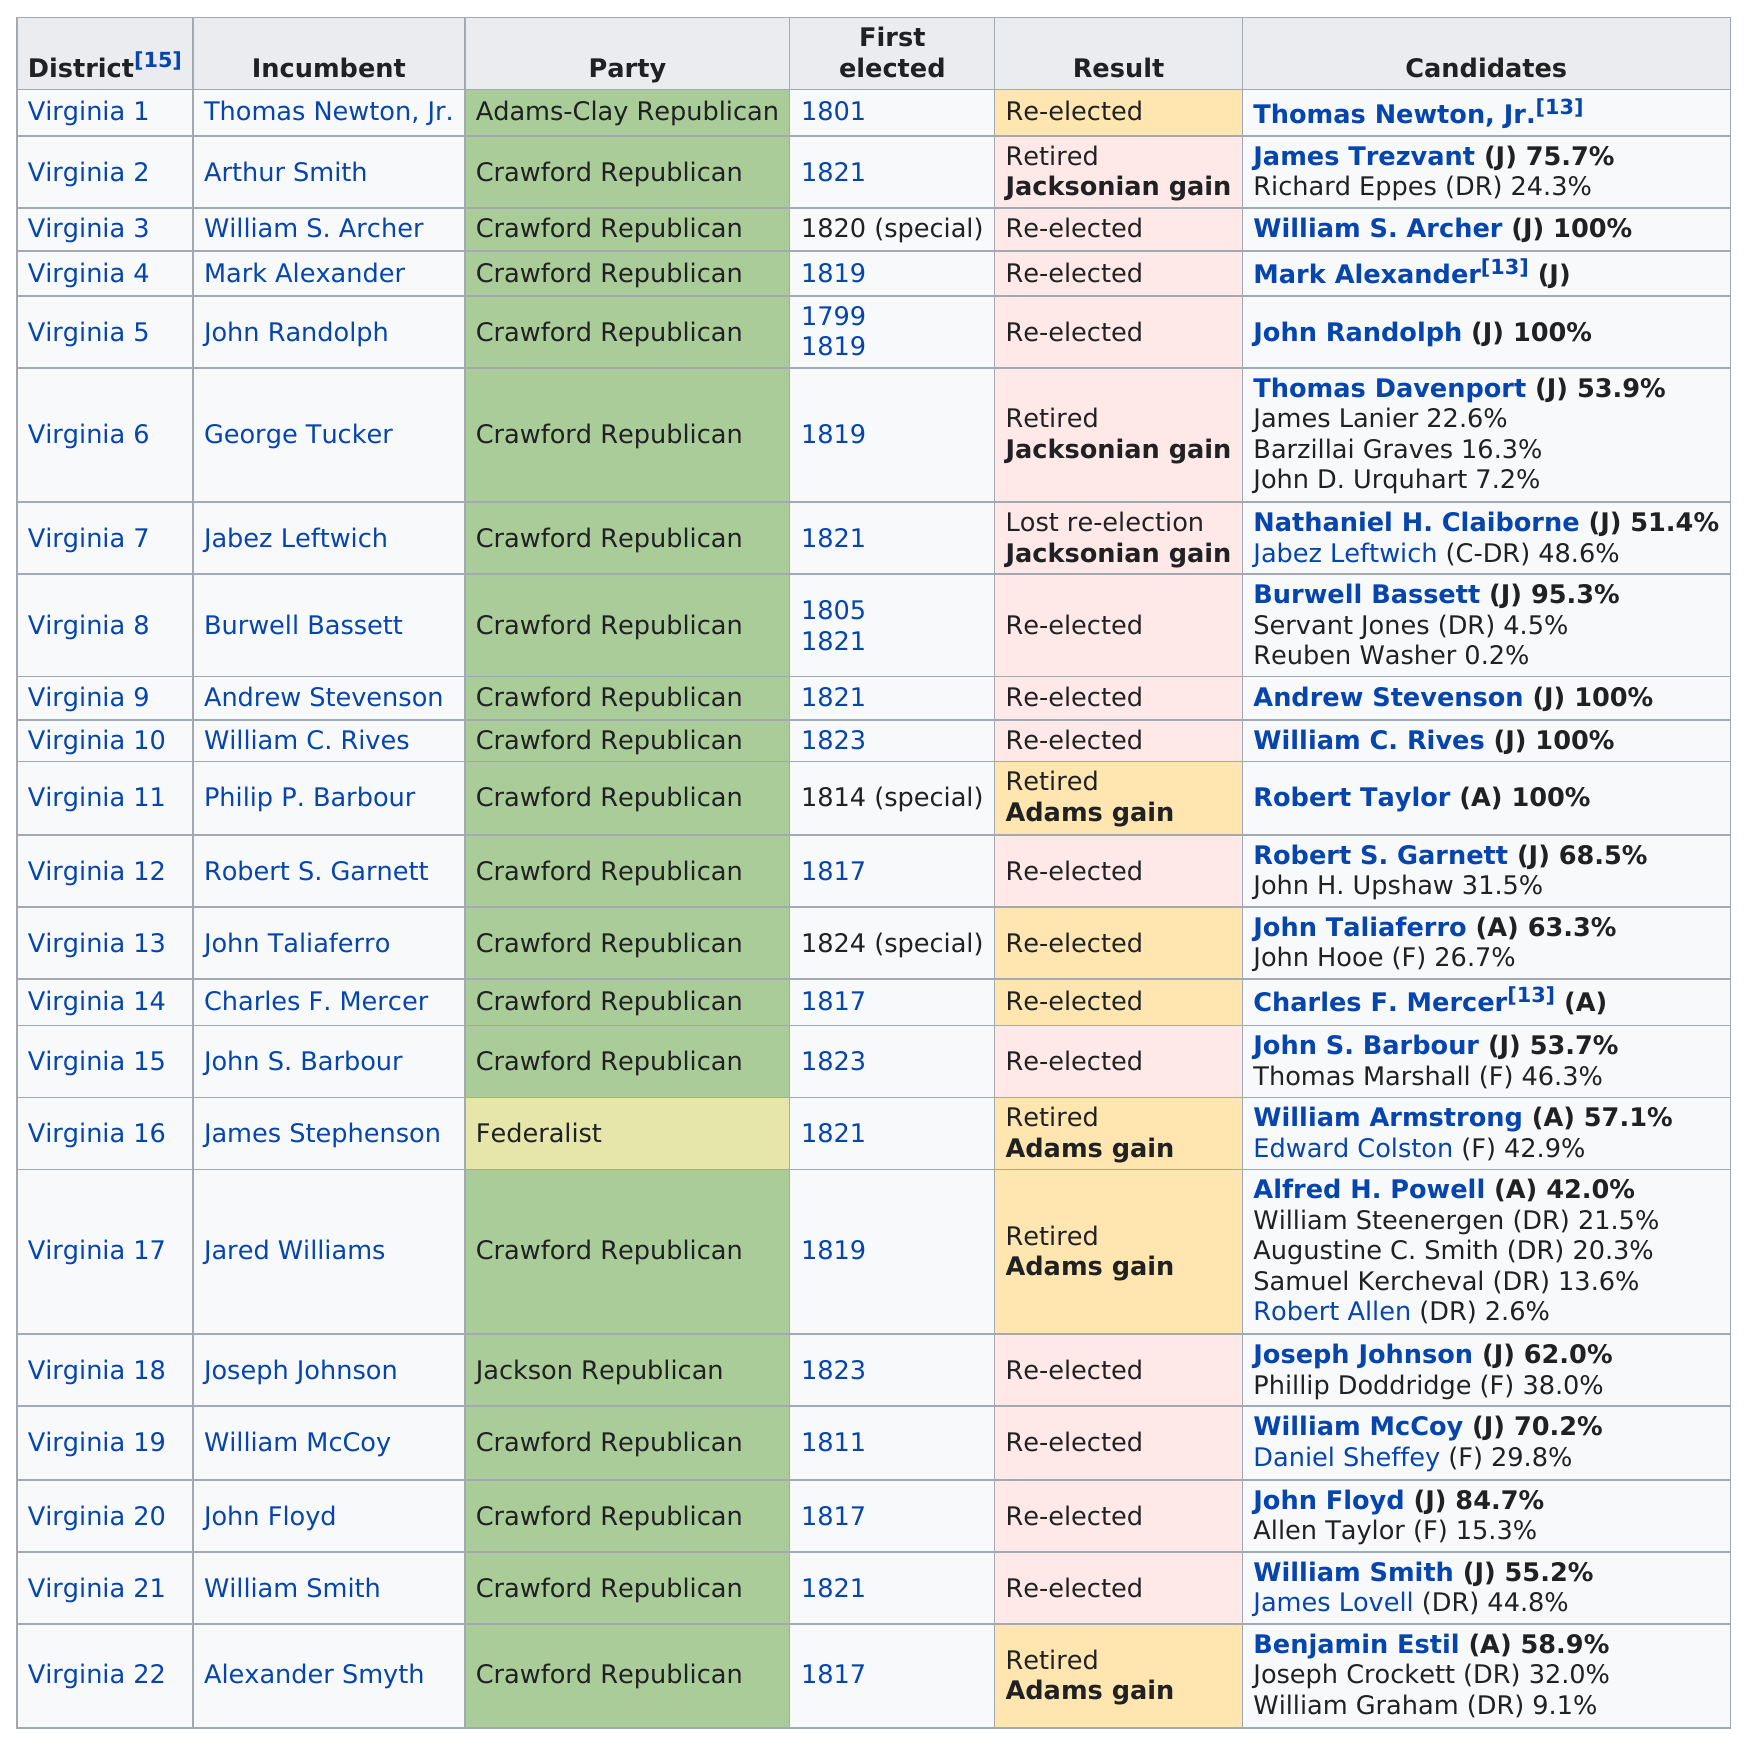Outline some significant characteristics in this image. The last party listed on this chart is the Crawford Republican Party. John Randolph was succeeded by George Tucker as the incumbent in office. The total number of parties represented is four. There were five candidates who ran for the Virginia 17th congressional district. The number of people first elected in 1817 was 4. 